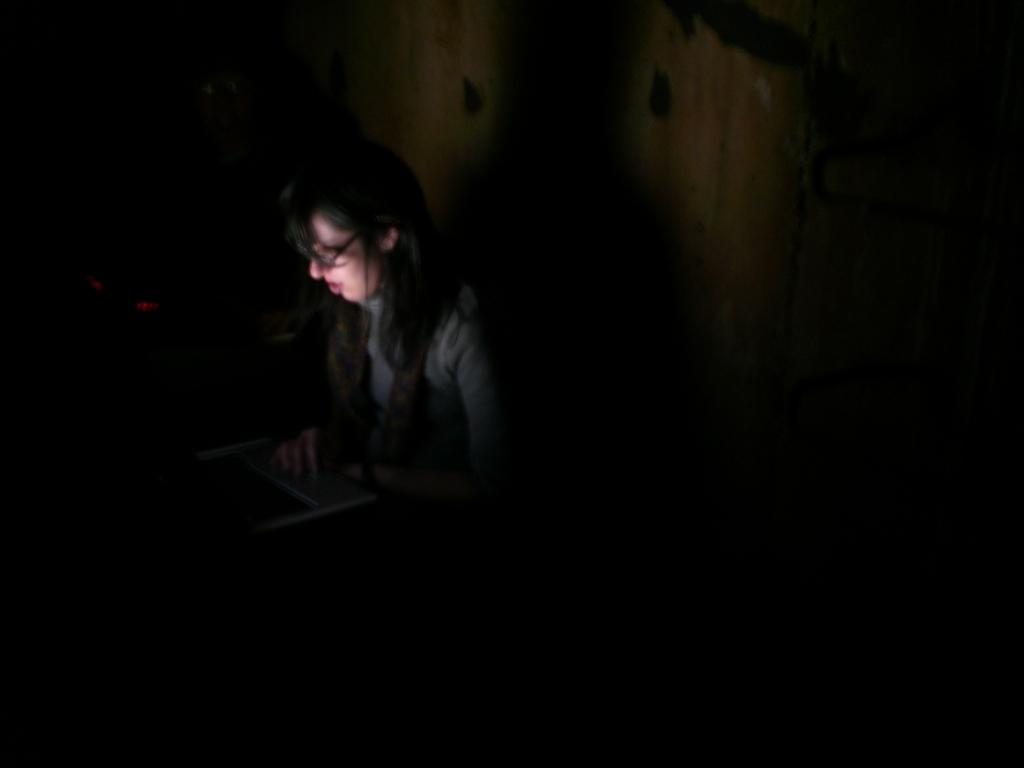What is the person in the image doing? The person is working on a computer. What can be seen in the background of the image? There is a wall in the background of the image. How would you describe the overall appearance of the image? The image has a dark appearance. How does the boy contribute to the quiet atmosphere in the image? There is no boy present in the image, and the image's quietness cannot be determined from the provided facts. 